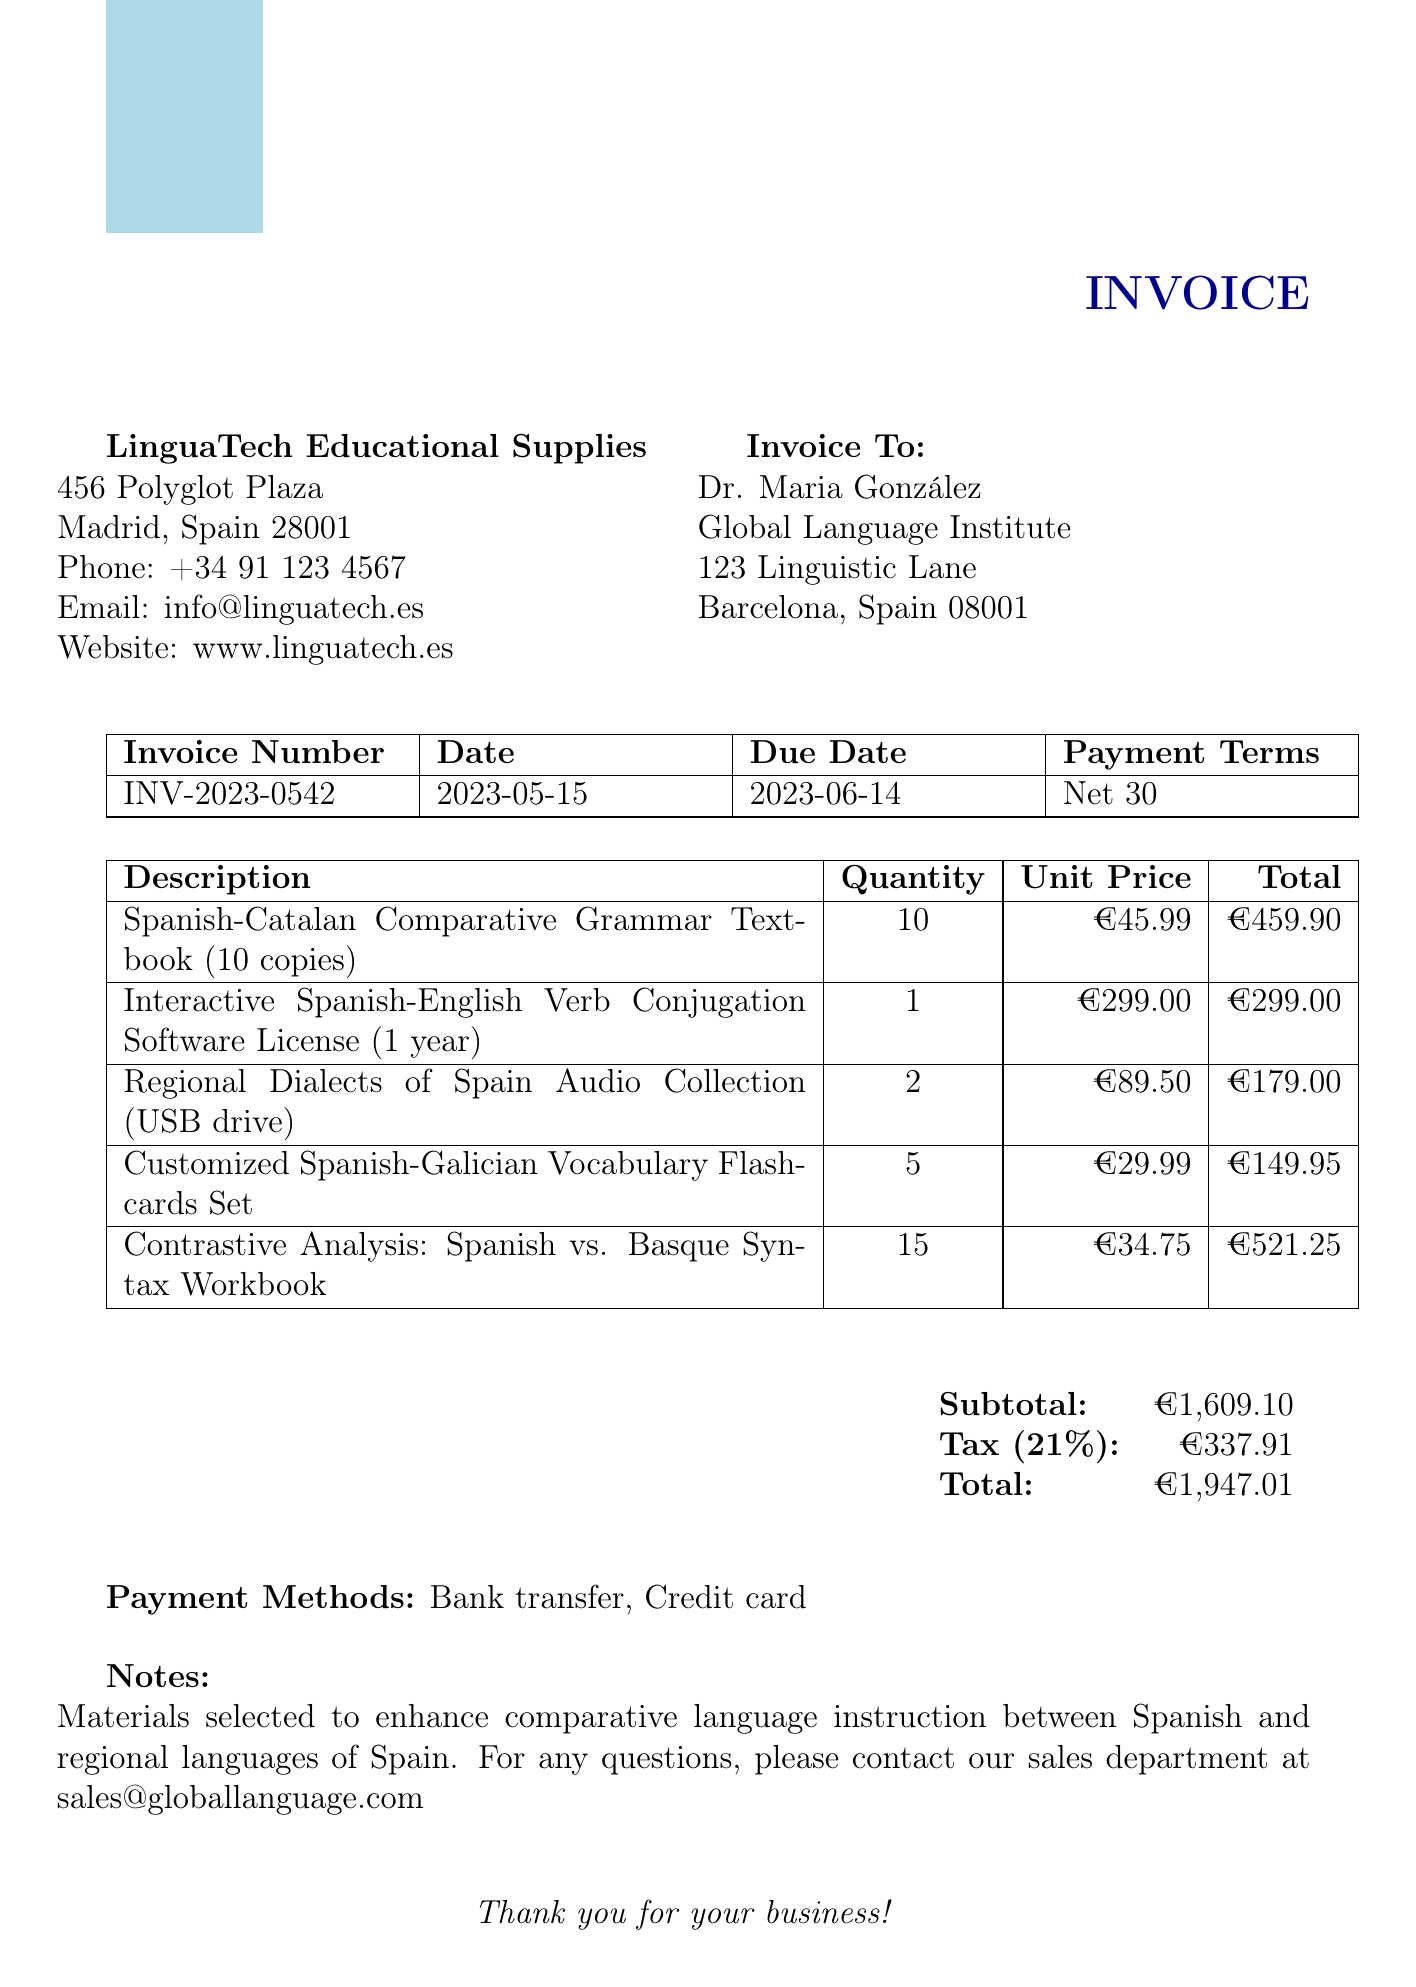What is the invoice number? The invoice number is listed in the document, identified as INV-2023-0542.
Answer: INV-2023-0542 What is the date of the invoice? The date of the invoice is specified clearly in the document.
Answer: 2023-05-15 What is the total amount due? The total amount is calculated from the subtotal and tax amounts presented in the invoice.
Answer: €1,947.01 Who is the instructor named on the invoice? The instructor's name is provided at the top of the invoice.
Answer: Dr. Maria González How many copies of the Spanish-Catalan Comparative Grammar Textbook were purchased? The quantity of textbooks bought is listed under the item description section.
Answer: 10 What is the tax rate applied to the invoice? The tax rate is mentioned in the subtotal section of the document.
Answer: 21% What type of payment methods are accepted? The payment methods are specified towards the end of the document.
Answer: Bank transfer, Credit card Which item had the highest total cost? The item totals are compared to determine which one is the highest.
Answer: Contrastive Analysis: Spanish vs. Basque Syntax Workbook What is the due date for payment? The due date for payment is found in the invoice information section.
Answer: 2023-06-14 